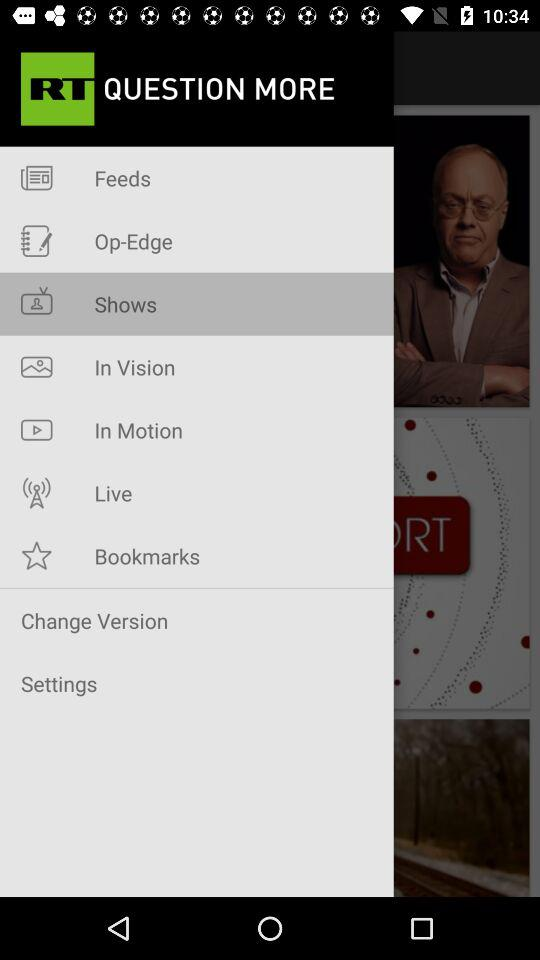What is the application name? The application name is "RT News". 